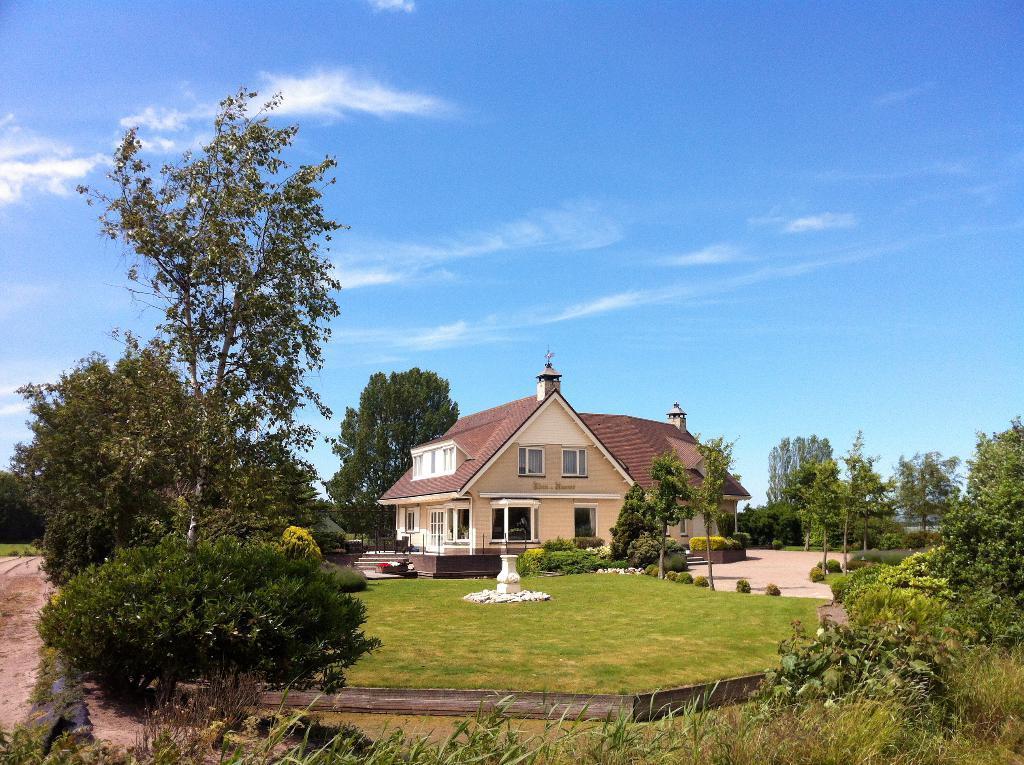In one or two sentences, can you explain what this image depicts? At the bottom of this image, there are buildings, trees, plants and grass on the ground. In the background, there are clouds in the blue sky. 